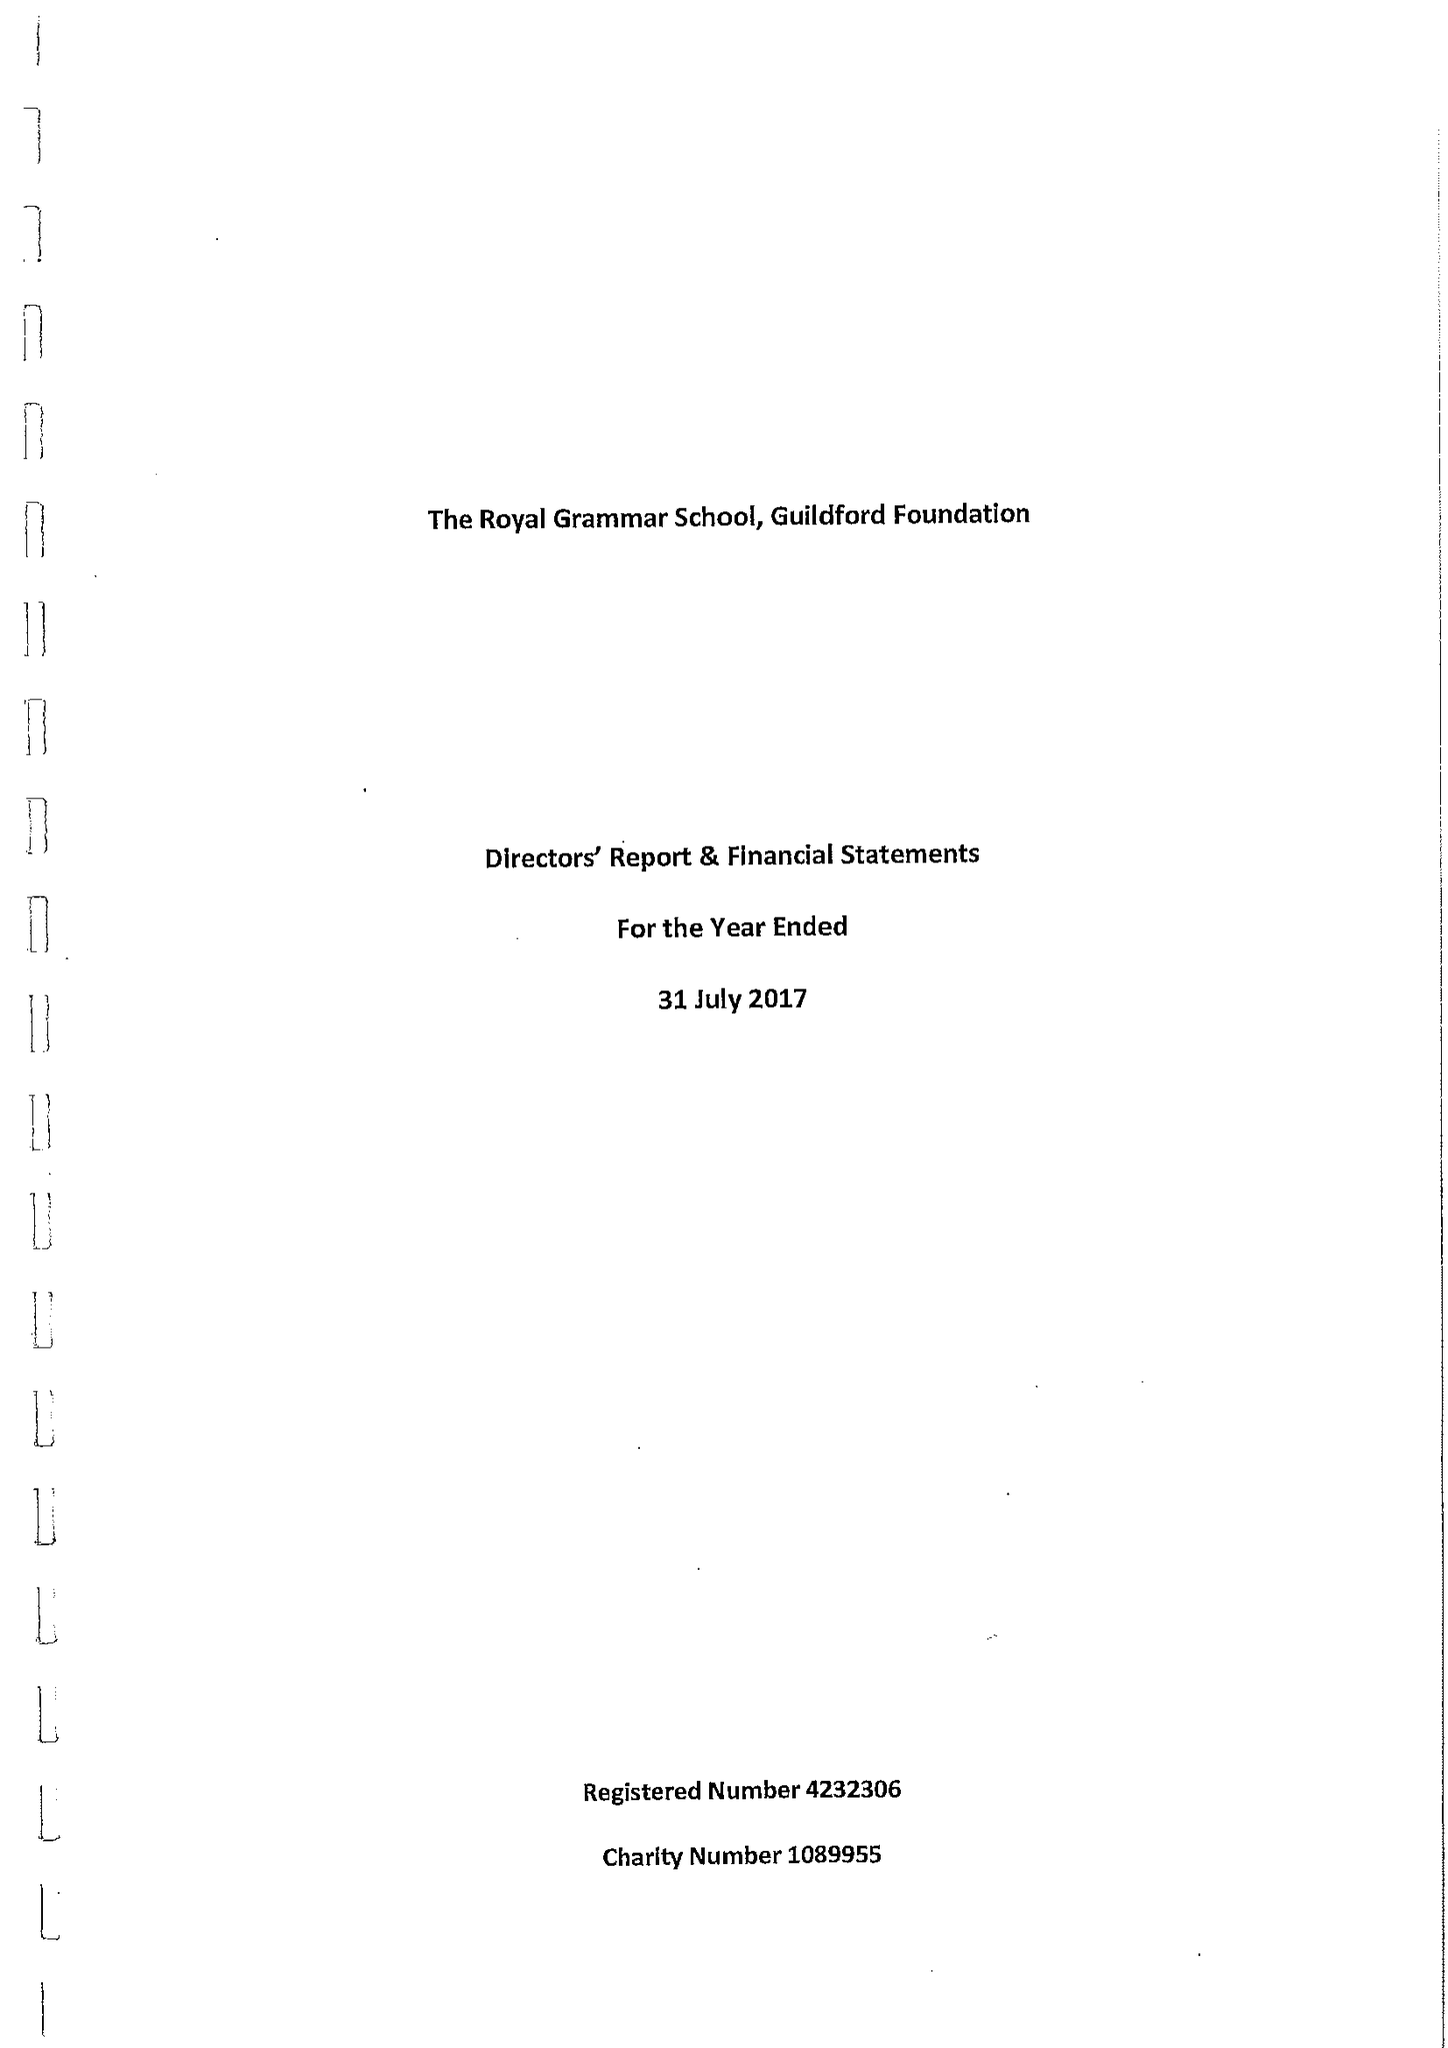What is the value for the report_date?
Answer the question using a single word or phrase. 2017-07-31 